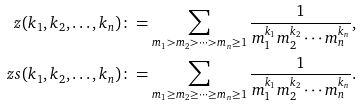Convert formula to latex. <formula><loc_0><loc_0><loc_500><loc_500>\ z ( k _ { 1 } , k _ { 2 } , \dots , k _ { n } ) \colon = \sum _ { m _ { 1 } > m _ { 2 } > \cdots > m _ { n } \geq 1 } \frac { 1 } { m _ { 1 } ^ { k _ { 1 } } m _ { 2 } ^ { k _ { 2 } } \cdots m _ { n } ^ { k _ { n } } } , \\ \ z s ( k _ { 1 } , k _ { 2 } , \dots , k _ { n } ) \colon = \sum _ { m _ { 1 } \geq m _ { 2 } \geq \cdots \geq m _ { n } \geq 1 } \frac { 1 } { m _ { 1 } ^ { k _ { 1 } } m _ { 2 } ^ { k _ { 2 } } \cdots m _ { n } ^ { k _ { n } } } .</formula> 